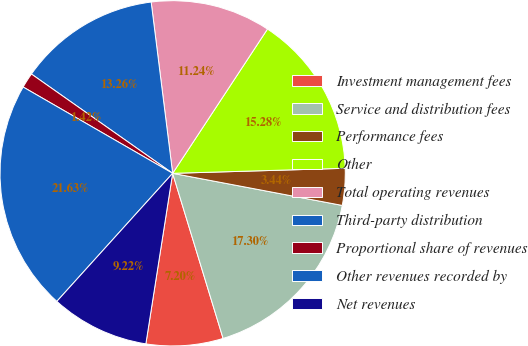Convert chart to OTSL. <chart><loc_0><loc_0><loc_500><loc_500><pie_chart><fcel>Investment management fees<fcel>Service and distribution fees<fcel>Performance fees<fcel>Other<fcel>Total operating revenues<fcel>Third-party distribution<fcel>Proportional share of revenues<fcel>Other revenues recorded by<fcel>Net revenues<nl><fcel>7.2%<fcel>17.3%<fcel>3.44%<fcel>15.28%<fcel>11.24%<fcel>13.26%<fcel>1.42%<fcel>21.63%<fcel>9.22%<nl></chart> 